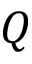<formula> <loc_0><loc_0><loc_500><loc_500>Q</formula> 